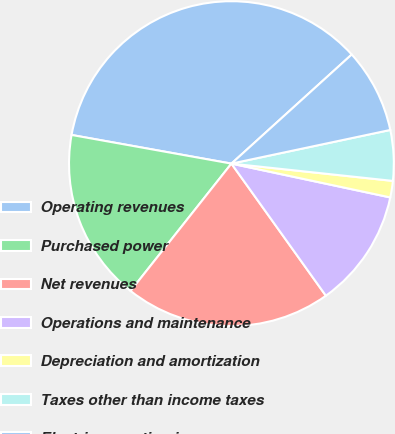Convert chart. <chart><loc_0><loc_0><loc_500><loc_500><pie_chart><fcel>Operating revenues<fcel>Purchased power<fcel>Net revenues<fcel>Operations and maintenance<fcel>Depreciation and amortization<fcel>Taxes other than income taxes<fcel>Electric operating income<nl><fcel>35.45%<fcel>17.16%<fcel>20.54%<fcel>11.78%<fcel>1.64%<fcel>5.02%<fcel>8.4%<nl></chart> 